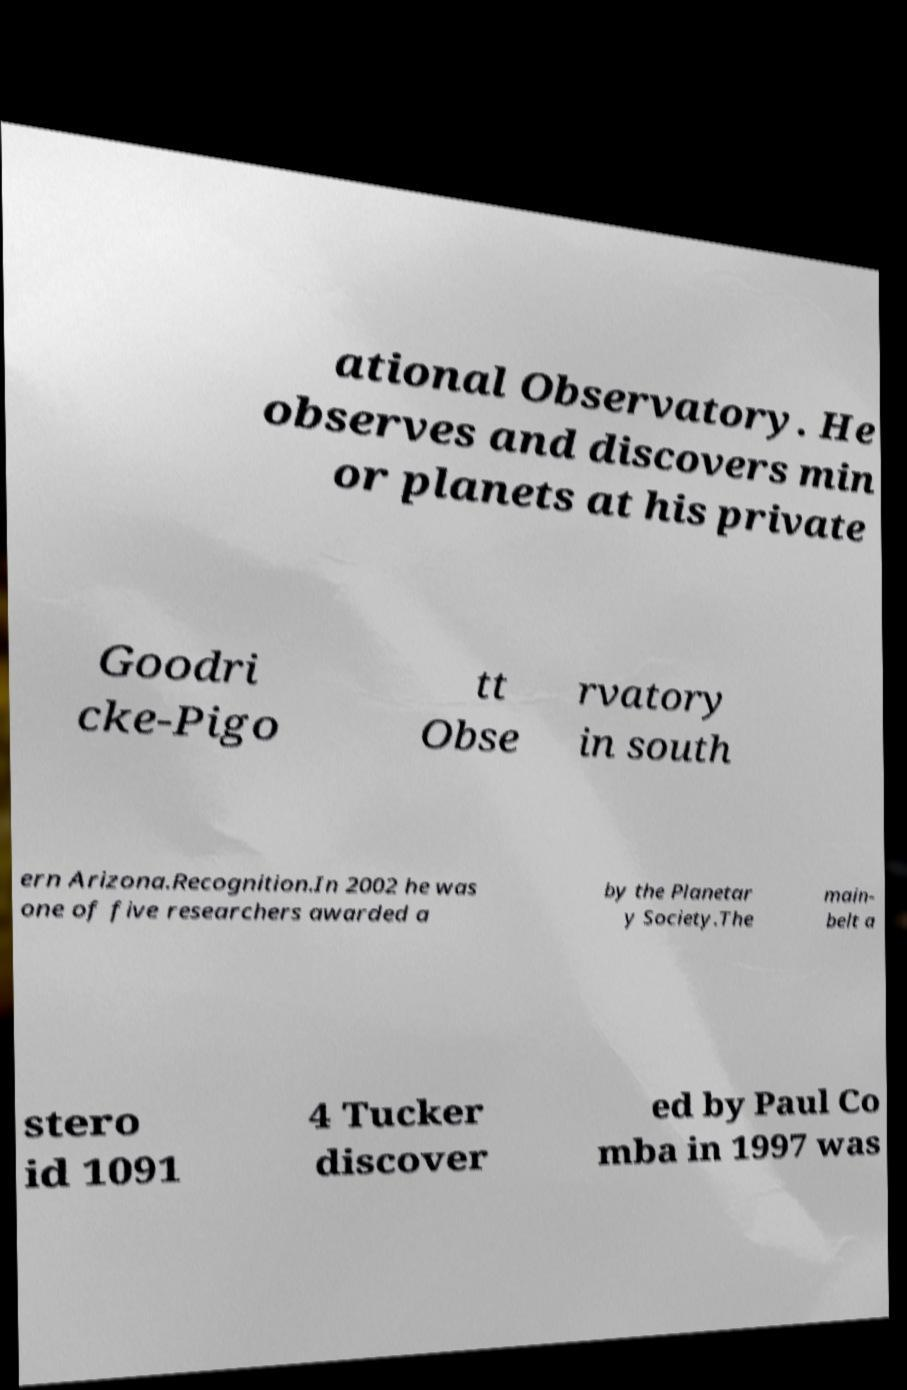Could you assist in decoding the text presented in this image and type it out clearly? ational Observatory. He observes and discovers min or planets at his private Goodri cke-Pigo tt Obse rvatory in south ern Arizona.Recognition.In 2002 he was one of five researchers awarded a by the Planetar y Society.The main- belt a stero id 1091 4 Tucker discover ed by Paul Co mba in 1997 was 